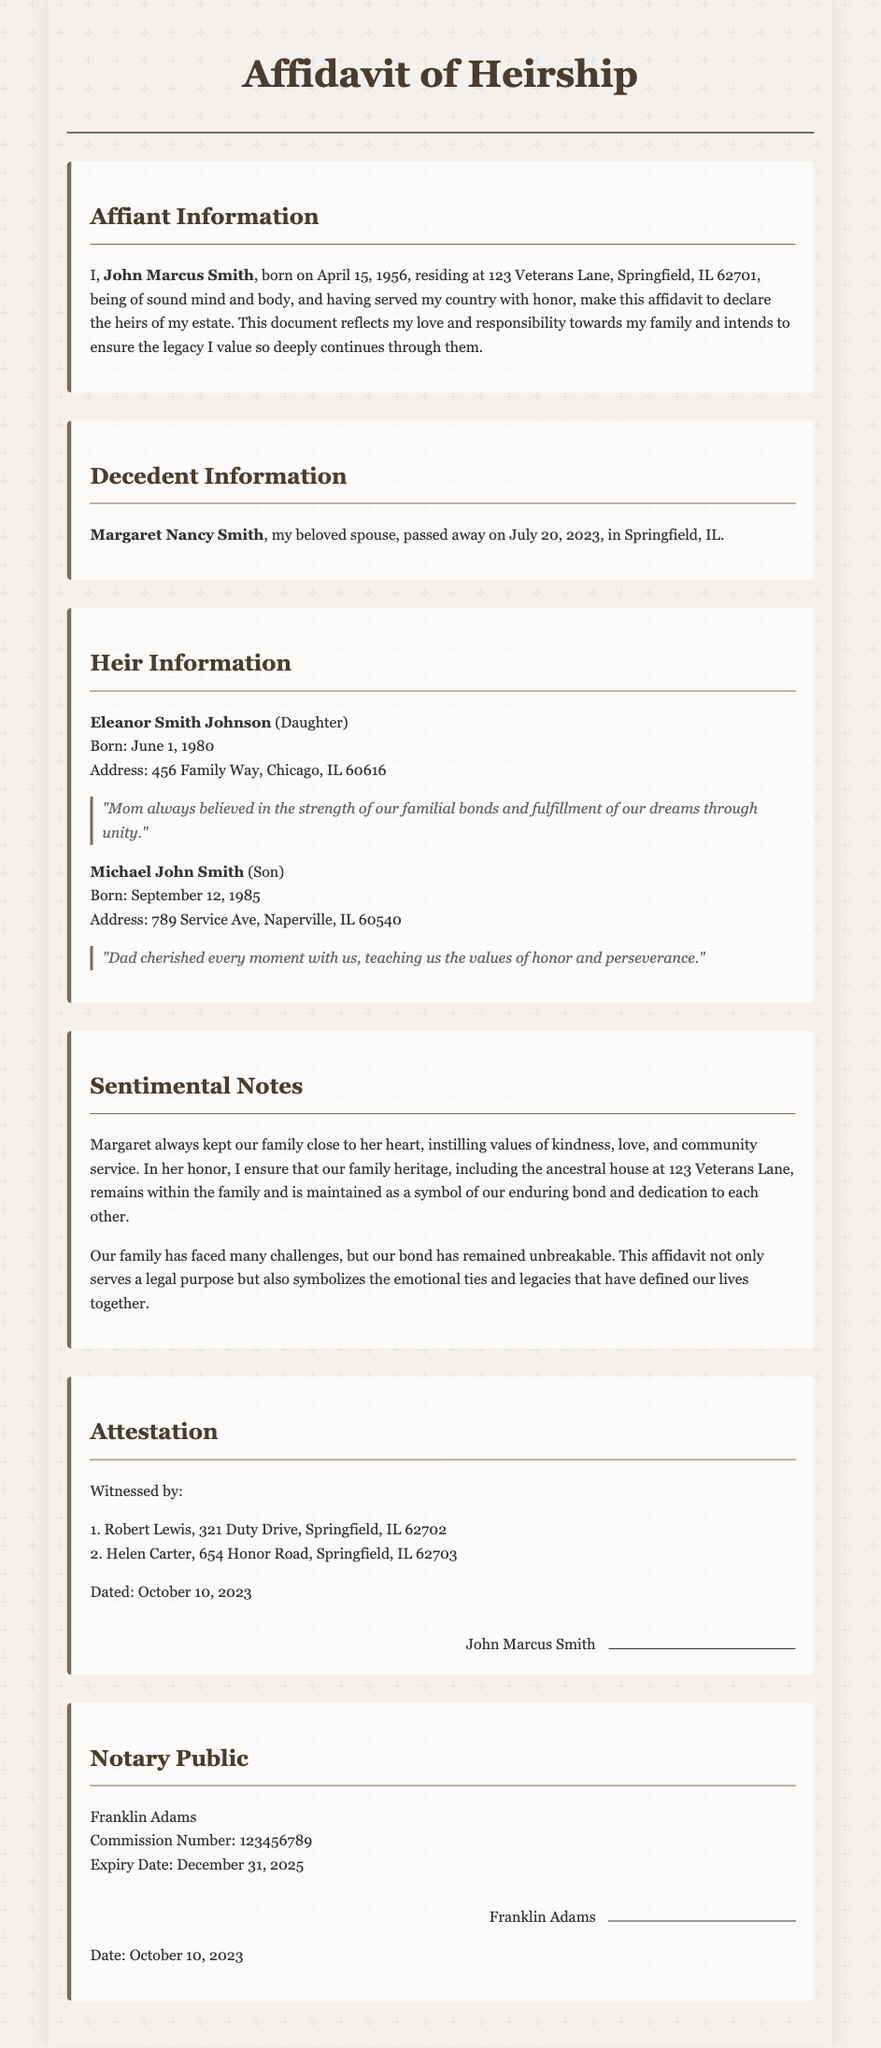What is the name of the affiant? The affiant's name is stated at the beginning of the document as John Marcus Smith.
Answer: John Marcus Smith When was Margaret Nancy Smith born? The birth date of Margaret Nancy Smith is not provided in the document, but her date of death is specified as July 20, 2023.
Answer: Not provided Who is the son of the affiant? The document clearly identifies the affiant's son as Michael John Smith.
Answer: Michael John Smith How many children does John Marcus Smith have? The heir information section lists two children, indicating the number of children.
Answer: Two What is the address of Eleanor Smith Johnson? The document provides Eleanor Smith Johnson's residence as 456 Family Way, Chicago, IL 60616.
Answer: 456 Family Way, Chicago, IL 60616 What is the date of the affidavit? The affidavit states the date it was signed as October 10, 2023.
Answer: October 10, 2023 What does the affidavit symbolize beyond legal purposes? It symbolizes emotional ties and legacies that have defined the lives of the family together.
Answer: Emotional ties and legacies Who witnessed the affidavit? The document lists Robert Lewis and Helen Carter as witnesses to the affidavit.
Answer: Robert Lewis and Helen Carter What is the name of the notary public? The name of the notary public is mentioned as Franklin Adams in the document.
Answer: Franklin Adams 